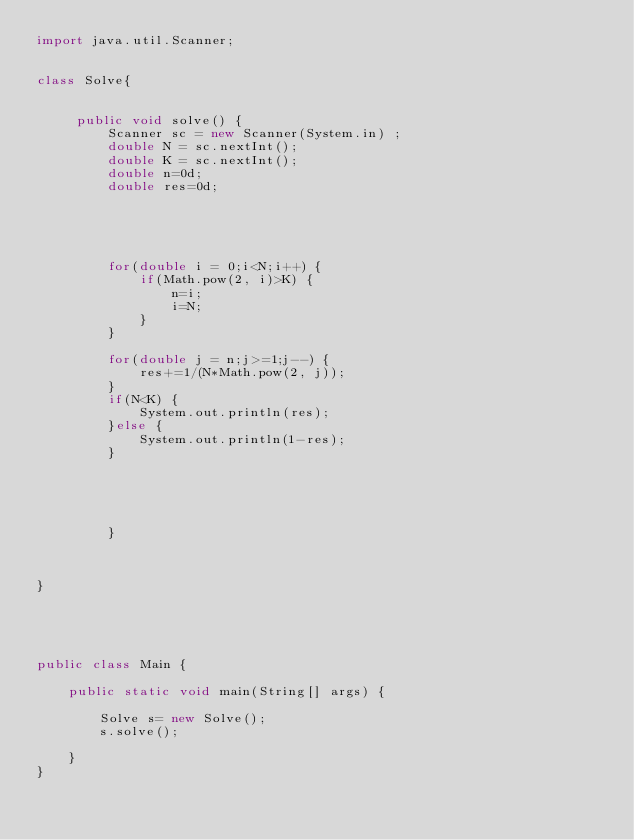<code> <loc_0><loc_0><loc_500><loc_500><_Java_>import java.util.Scanner;


class Solve{

	
	 public void solve() {
		 Scanner sc = new Scanner(System.in) ;
		 double N = sc.nextInt();
		 double K = sc.nextInt();
		 double n=0d;
		 double res=0d;
		 
		 
		
		 
		 
		 for(double i = 0;i<N;i++) {
			 if(Math.pow(2, i)>K) {
				 n=i;
				 i=N;
			 }
		 }
		 
		 for(double j = n;j>=1;j--) {
			 res+=1/(N*Math.pow(2, j));
		 }
		 if(N<K) {
			 System.out.println(res);
		 }else {
			 System.out.println(1-res);
		 }
		 
		 
		 
		

		 }
	

	 
}





public class Main {

	public static void main(String[] args) {

		Solve s= new Solve();
		s.solve();

	}
}</code> 